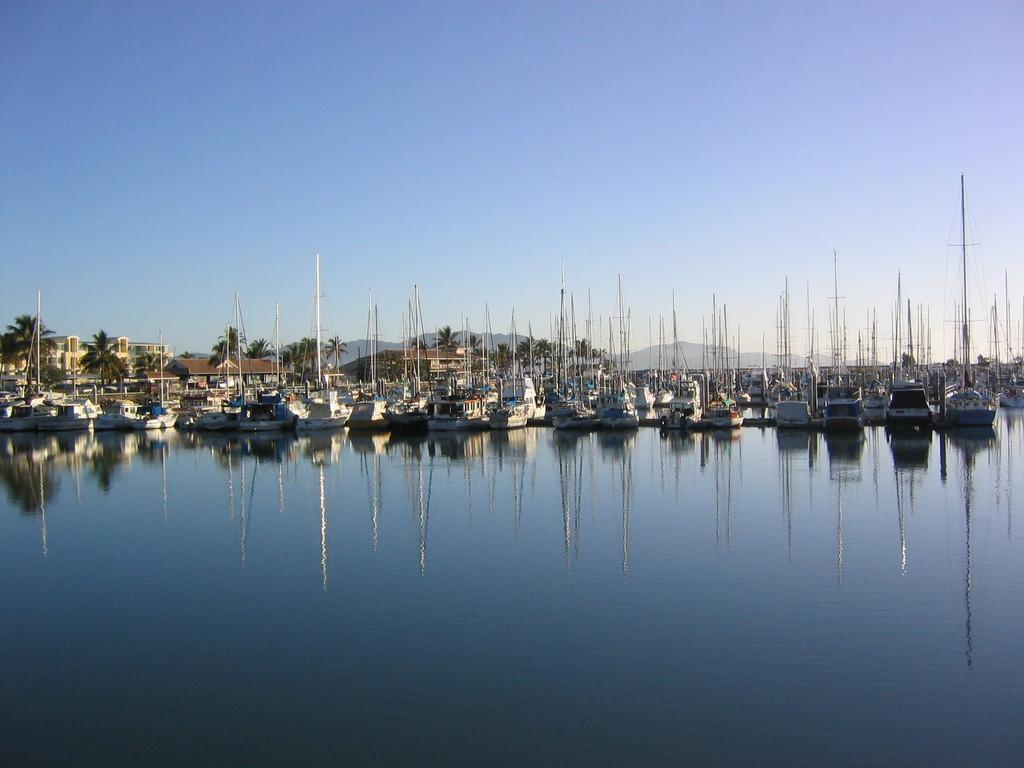Could you give a brief overview of what you see in this image? In this image I can see few ships on the water. Background I can see few buildings in brown and cream color, trees in green color and the sky is in blue color. 